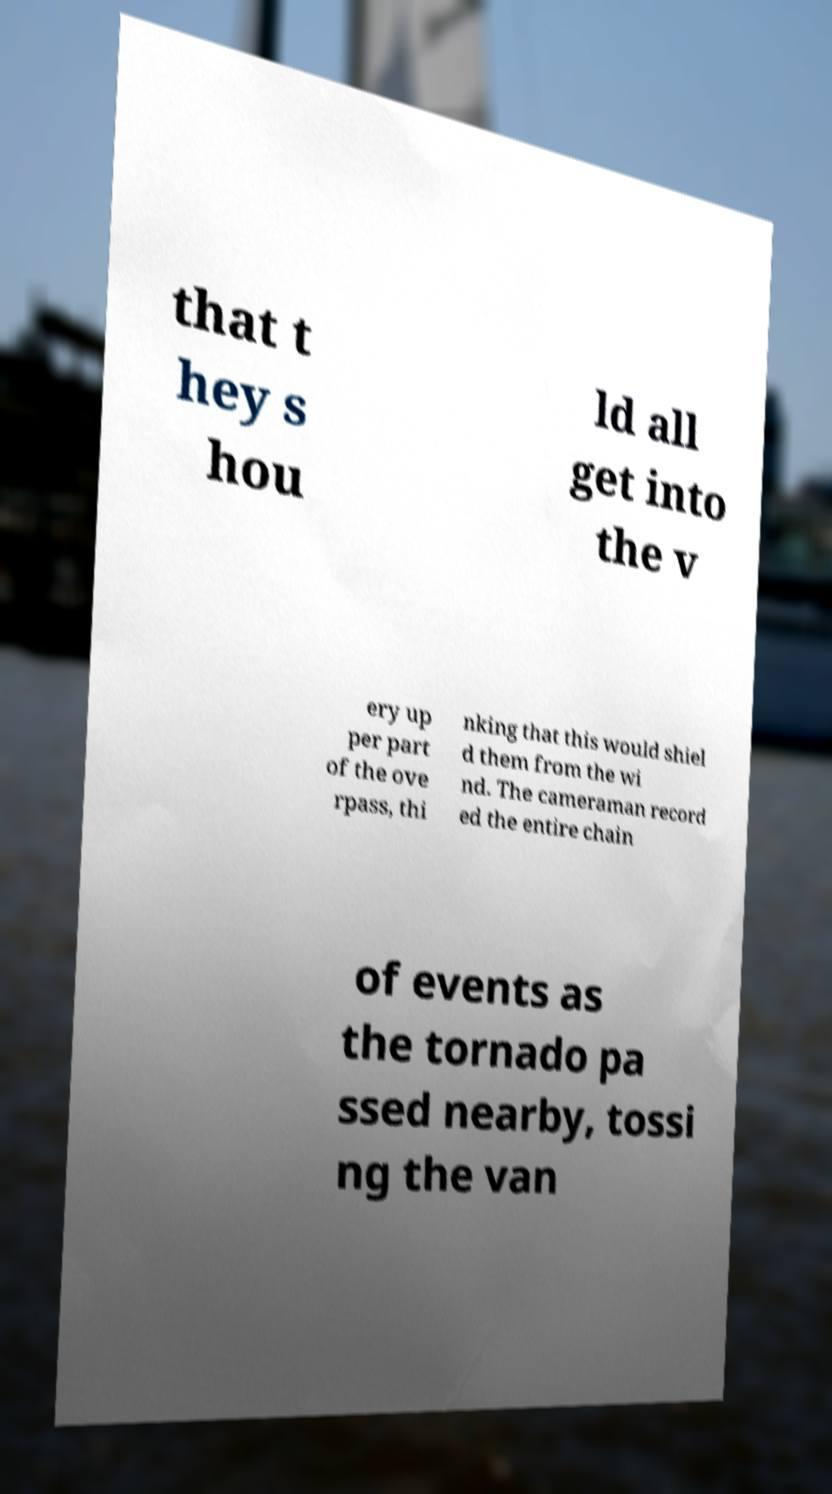Can you read and provide the text displayed in the image?This photo seems to have some interesting text. Can you extract and type it out for me? that t hey s hou ld all get into the v ery up per part of the ove rpass, thi nking that this would shiel d them from the wi nd. The cameraman record ed the entire chain of events as the tornado pa ssed nearby, tossi ng the van 